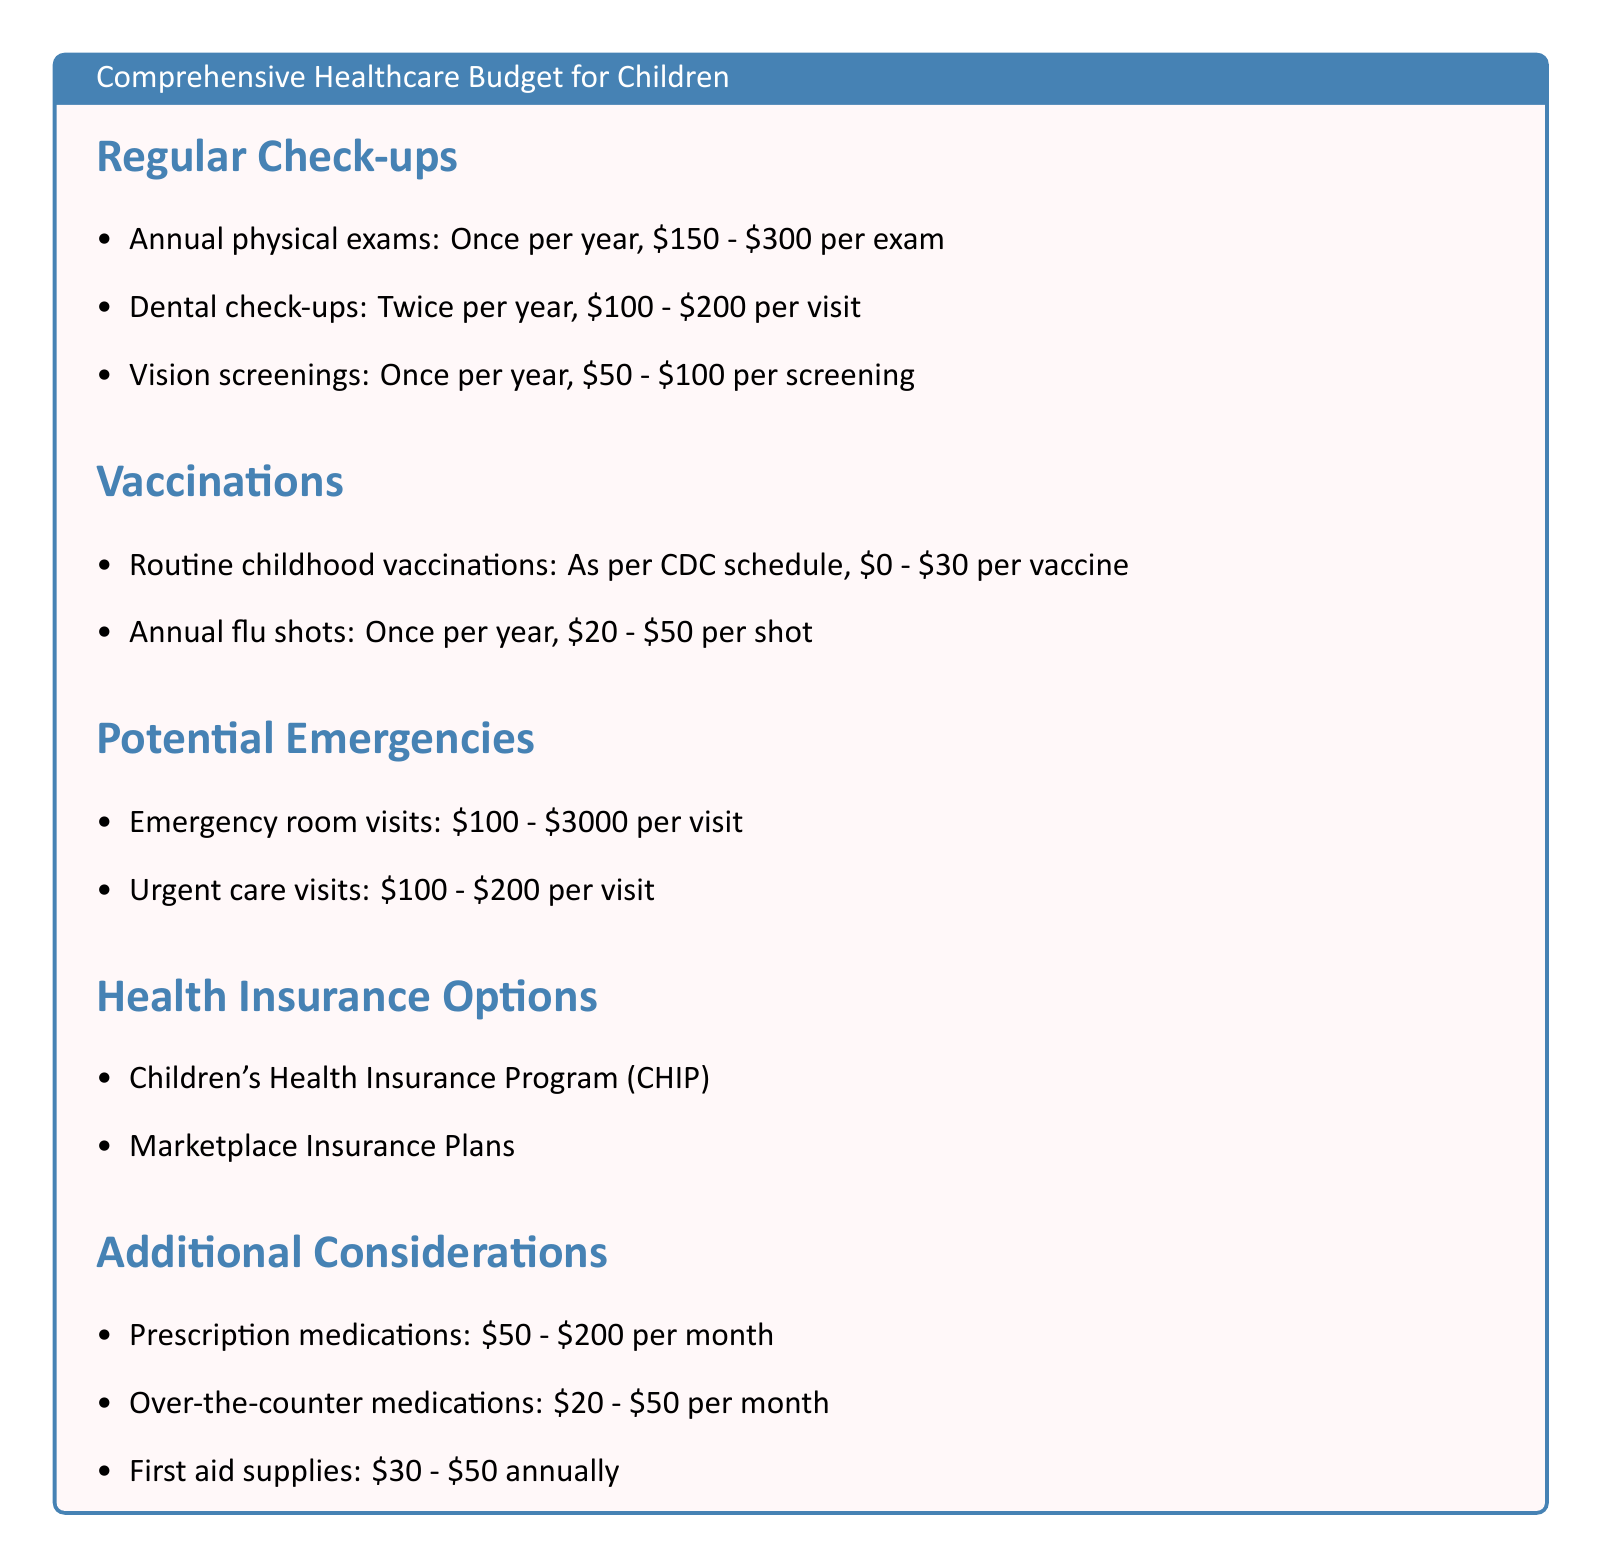What is the cost range for annual physical exams? The document provides that the cost for annual physical exams ranges from $150 to $300 per exam.
Answer: $150 - $300 How often should dental check-ups occur? The document states that dental check-ups should occur twice per year.
Answer: Twice per year What is the cost of routine childhood vaccinations? The document indicates that routine childhood vaccinations can cost between $0 and $30 per vaccine.
Answer: $0 - $30 What is the potential cost for an emergency room visit? According to the document, an emergency room visit can cost anywhere from $100 to $3000.
Answer: $100 - $3000 What health insurance program is listed in the document? The document mentions the Children's Health Insurance Program (CHIP) among other options.
Answer: Children's Health Insurance Program (CHIP) What is the estimated monthly cost for prescription medications? The document states that prescription medications can cost between $50 and $200 per month.
Answer: $50 - $200 How many vision screenings are suggested per year? The document suggests having one vision screening per year.
Answer: Once per year What is the cost range for urgent care visits? The document lists the cost for urgent care visits as being between $100 and $200.
Answer: $100 - $200 What additional supplies are mentioned in the budget? The document lists first aid supplies as an additional consideration.
Answer: First aid supplies 